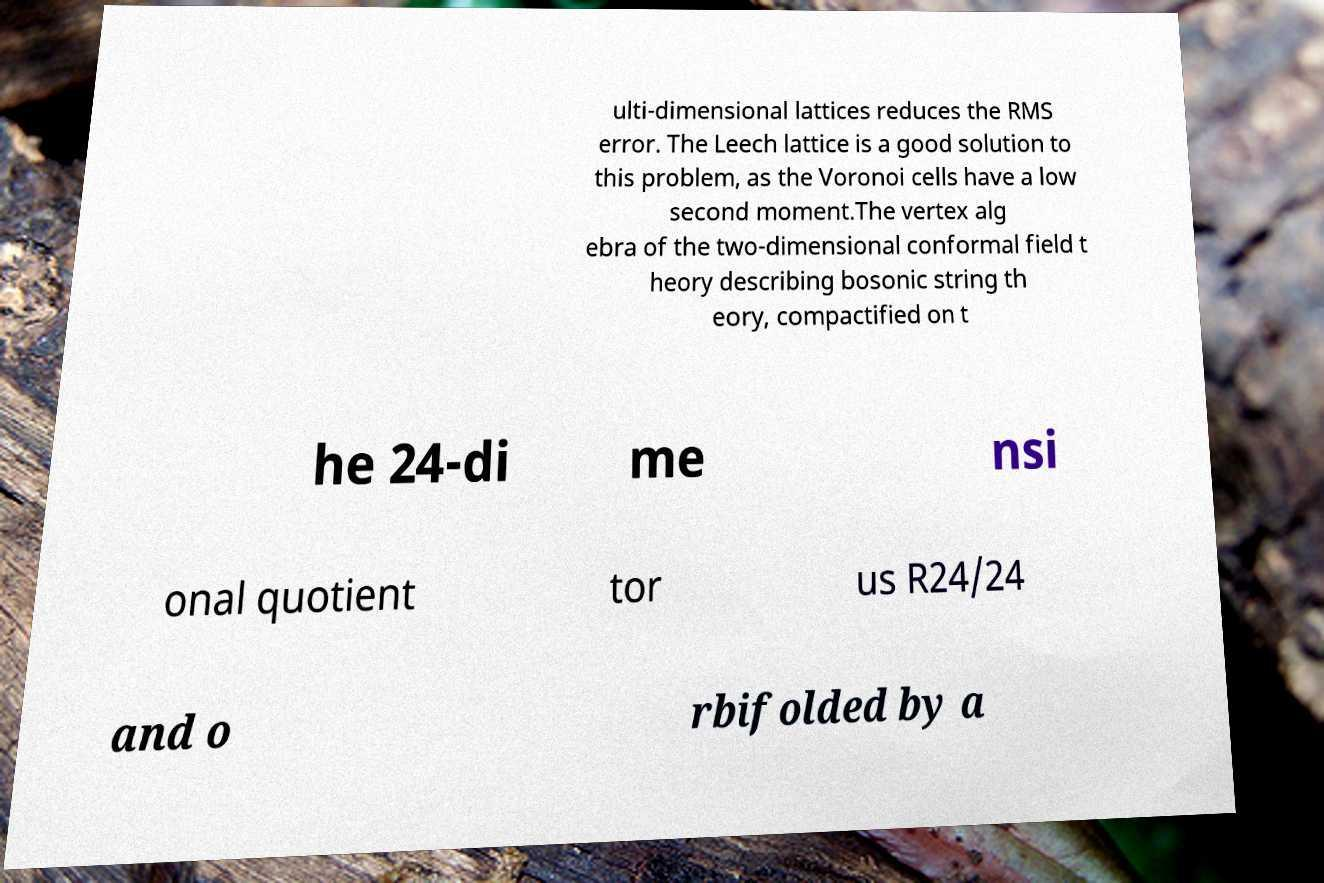Can you read and provide the text displayed in the image?This photo seems to have some interesting text. Can you extract and type it out for me? ulti-dimensional lattices reduces the RMS error. The Leech lattice is a good solution to this problem, as the Voronoi cells have a low second moment.The vertex alg ebra of the two-dimensional conformal field t heory describing bosonic string th eory, compactified on t he 24-di me nsi onal quotient tor us R24/24 and o rbifolded by a 